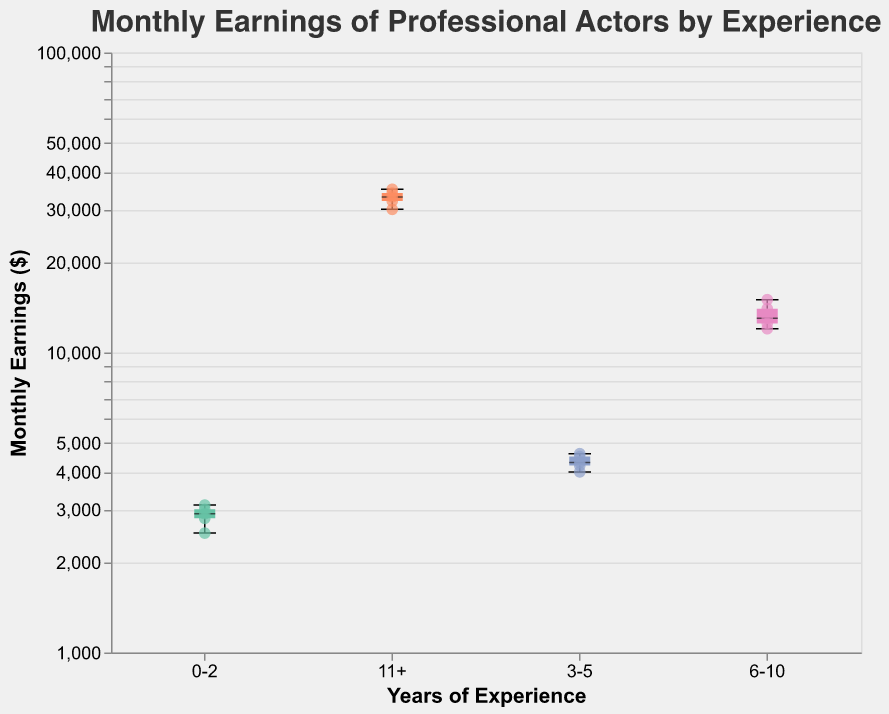What is the title of the plot? The title of the plot is located at the top center of the figure and reads "Monthly Earnings of Professional Actors by Experience".
Answer: Monthly Earnings of Professional Actors by Experience Which category has actors with the highest median monthly earnings? To find the category with the highest median monthly earnings, observe the middle line inside the box plots for each category. The category "11+" has the highest median.
Answer: 11+ What's the range of monthly earnings for actors with 0-2 years of experience? Observe the ends of the whiskers for the 0-2 years category, which show the minimum and maximum earnings. The range is from $2,500 to $3,100.
Answer: $2,500 - $3,100 How many individual data points (actors) are there in the 6-10 years of experience category? Each scatter point represents an actor. Count the points in the 6-10 years experience category, which is 5.
Answer: 5 What is the difference between the highest and lowest monthly earnings in the 3-5 years of experience category? The maximum and minimum values from the whiskers in the 3-5 years category are $4,600 and $4,000 respectively. The difference is $4,600 - $4,000 = $600.
Answer: $600 Which actor has the highest monthly earnings, and in which experience category do they belong? Identify the highest scatter point, which represents Meryl Streep with monthly earnings of $35,000 in the 11+ years category.
Answer: Meryl Streep, 11+ What is the interquartile range (IQR) for the actors with 6-10 years of experience? The IQR is the difference between the third quartile (Q3) and the first quartile (Q1). Observe the edges of the box for 6-10 years of experience. Q3 is around $14,000, and Q1 is around $12,500. The IQR is $14,000 - $12,500 = $1,500.
Answer: $1,500 Which experience category shows the most variability in monthly earnings? The category with the widest range between the minimum and maximum whiskers represents the most variability. The 11+ years category shows the most variability with monthly earnings ranging from $30,000 to $35,000.
Answer: 11+ Between 3-5 years and 6-10 years categories, which one has actors with higher monthly earnings on average? Calculate the average monthly earnings for each category by summing the earnings of the actors and dividing by the number of actors. For 3-5 years, the sum is (4500 + 4000 + 4200 + 4600 + 4300) = 21600, and the average is 21600/5 = 4320. For 6-10 years, the sum is (12000 + 15000 + 14000 + 13000 + 12500) = 66500, and the average is 66500/5 = 13300. Hence, 6-10 years has higher monthly earnings on average.
Answer: 6-10 years What can be inferred about the relationship between years of experience and monthly earnings based on the plot? Examine the trend in the data points and box plots across the experience categories. As the years of experience increase, the median, minimum, and maximum earnings increase as well, indicating a positive correlation between experience and monthly earnings.
Answer: Positive correlation 